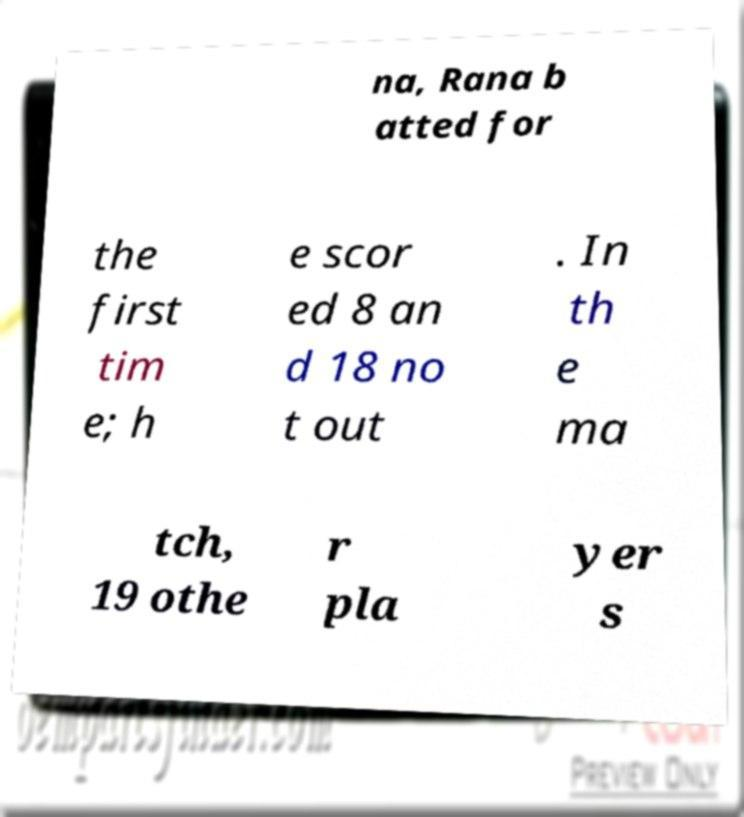Can you accurately transcribe the text from the provided image for me? na, Rana b atted for the first tim e; h e scor ed 8 an d 18 no t out . In th e ma tch, 19 othe r pla yer s 